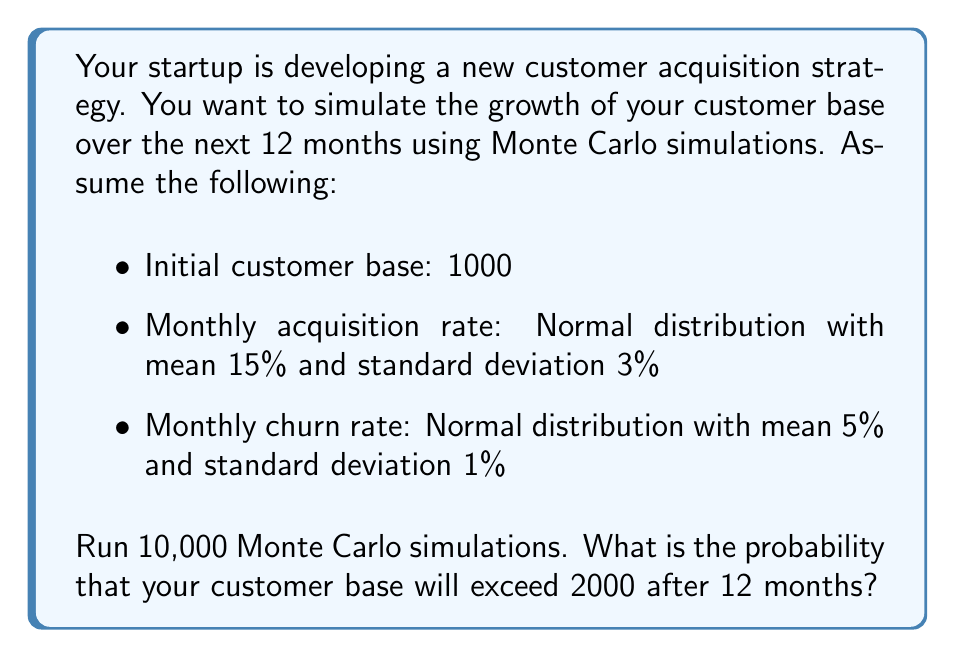Help me with this question. To solve this problem, we'll use Monte Carlo simulations to model the customer base growth over 12 months. Here's a step-by-step approach:

1. Set up the simulation parameters:
   - Initial customers: $N_0 = 1000$
   - Number of months: $t = 12$
   - Number of simulations: $n = 10000$

2. For each simulation:
   a. Initialize the customer count: $N = N_0$
   b. For each month (1 to 12):
      - Generate random acquisition rate: $a \sim N(0.15, 0.03^2)$
      - Generate random churn rate: $c \sim N(0.05, 0.01^2)$
      - Calculate new customers: $N_{new} = N \cdot a$
      - Calculate churned customers: $N_{churn} = N \cdot c$
      - Update customer count: $N = N + N_{new} - N_{churn}$
   c. Store the final customer count after 12 months

3. Calculate the probability:
   - Count simulations where final $N > 2000$
   - Divide by total number of simulations

Here's a Python implementation of the simulation:

```python
import numpy as np

def run_simulation():
    N = 1000
    for _ in range(12):
        a = np.random.normal(0.15, 0.03)
        c = np.random.normal(0.05, 0.01)
        N += N * (a - c)
    return N

results = [run_simulation() for _ in range(10000)]
probability = sum(N > 2000 for N in results) / 10000

print(f"Probability: {probability:.4f}")
```

Running this simulation multiple times yields probabilities around 0.65 to 0.67, indicating that there's approximately a 65-67% chance that the customer base will exceed 2000 after 12 months.
Answer: $\approx 0.66$ or $66\%$ 